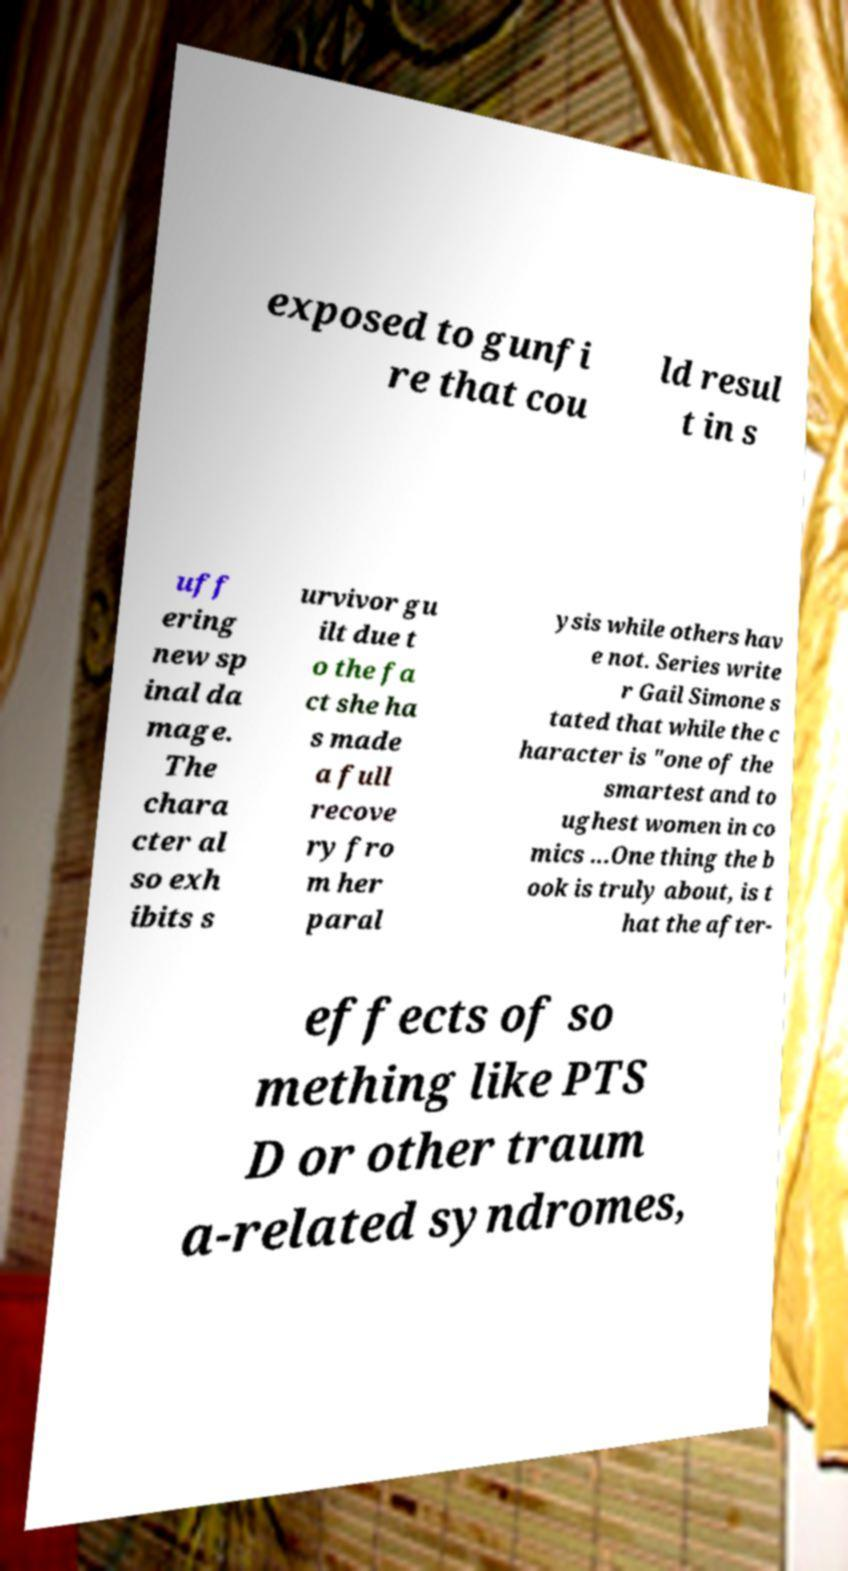Please read and relay the text visible in this image. What does it say? exposed to gunfi re that cou ld resul t in s uff ering new sp inal da mage. The chara cter al so exh ibits s urvivor gu ilt due t o the fa ct she ha s made a full recove ry fro m her paral ysis while others hav e not. Series write r Gail Simone s tated that while the c haracter is "one of the smartest and to ughest women in co mics ...One thing the b ook is truly about, is t hat the after- effects of so mething like PTS D or other traum a-related syndromes, 